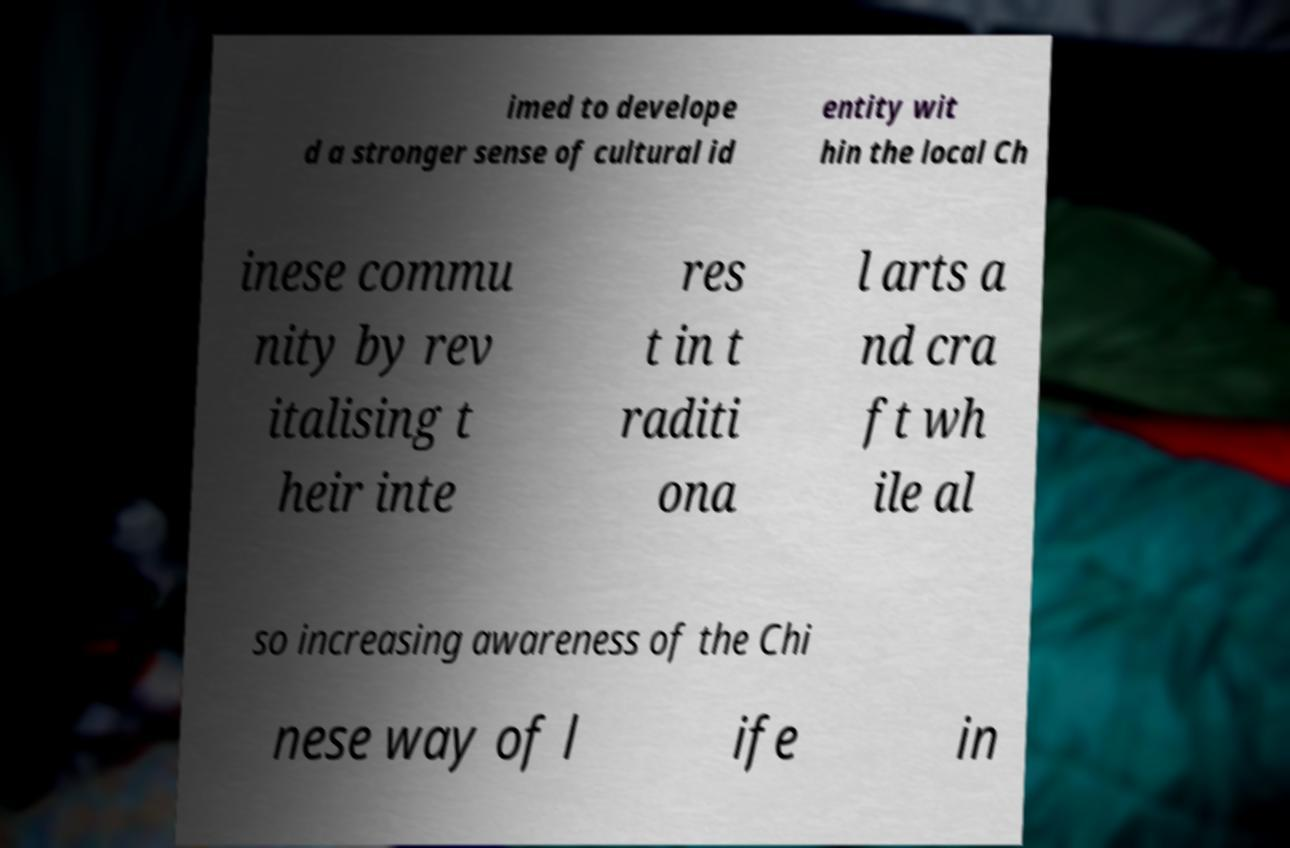I need the written content from this picture converted into text. Can you do that? imed to develope d a stronger sense of cultural id entity wit hin the local Ch inese commu nity by rev italising t heir inte res t in t raditi ona l arts a nd cra ft wh ile al so increasing awareness of the Chi nese way of l ife in 